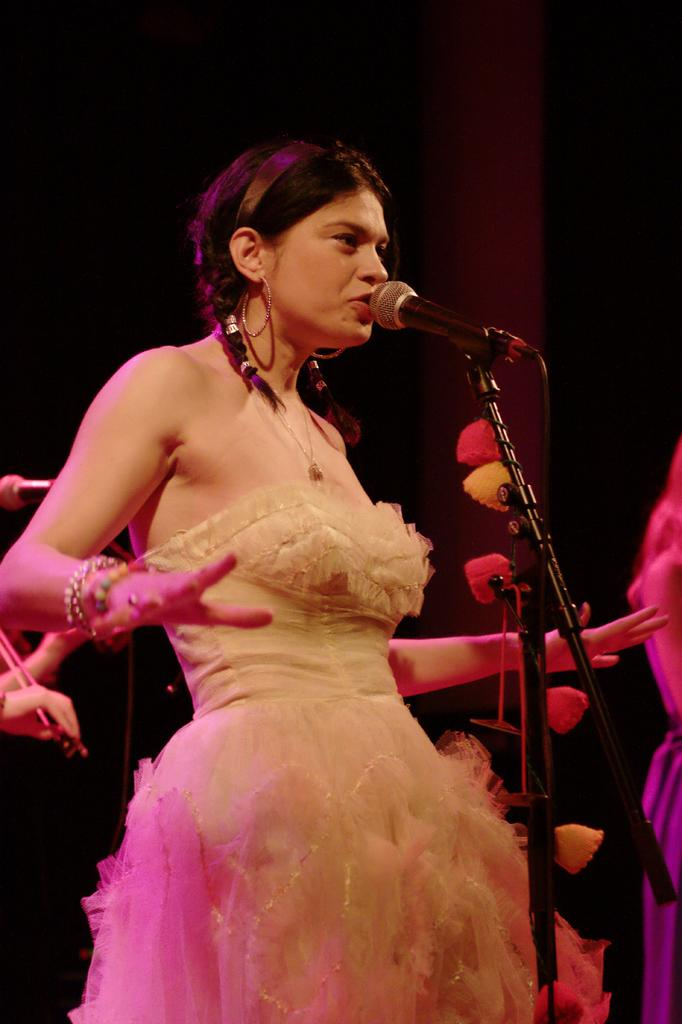What is the main subject of the image? There is a woman standing in the image. What object is in front of the woman? There is a microphone on a stand in front of the woman. What can be seen behind the woman? There are hands of a person and a microphone behind the woman. How would you describe the background of the image? The background of the image is dark. What type of health issues does the woman in the image have with her knee? There is no information about the woman's health or her knee in the image. Can you tell me how many hydrants are visible in the image? There are no hydrants present in the image. 